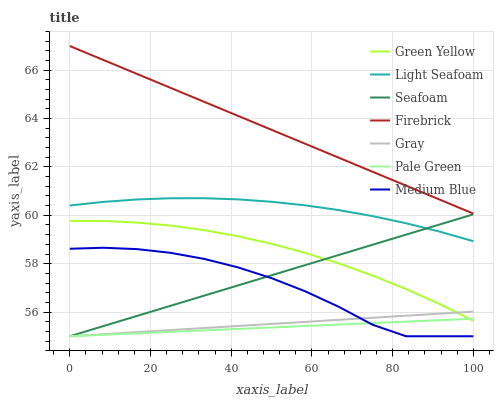Does Light Seafoam have the minimum area under the curve?
Answer yes or no. No. Does Light Seafoam have the maximum area under the curve?
Answer yes or no. No. Is Light Seafoam the smoothest?
Answer yes or no. No. Is Light Seafoam the roughest?
Answer yes or no. No. Does Light Seafoam have the lowest value?
Answer yes or no. No. Does Light Seafoam have the highest value?
Answer yes or no. No. Is Medium Blue less than Green Yellow?
Answer yes or no. Yes. Is Firebrick greater than Seafoam?
Answer yes or no. Yes. Does Medium Blue intersect Green Yellow?
Answer yes or no. No. 